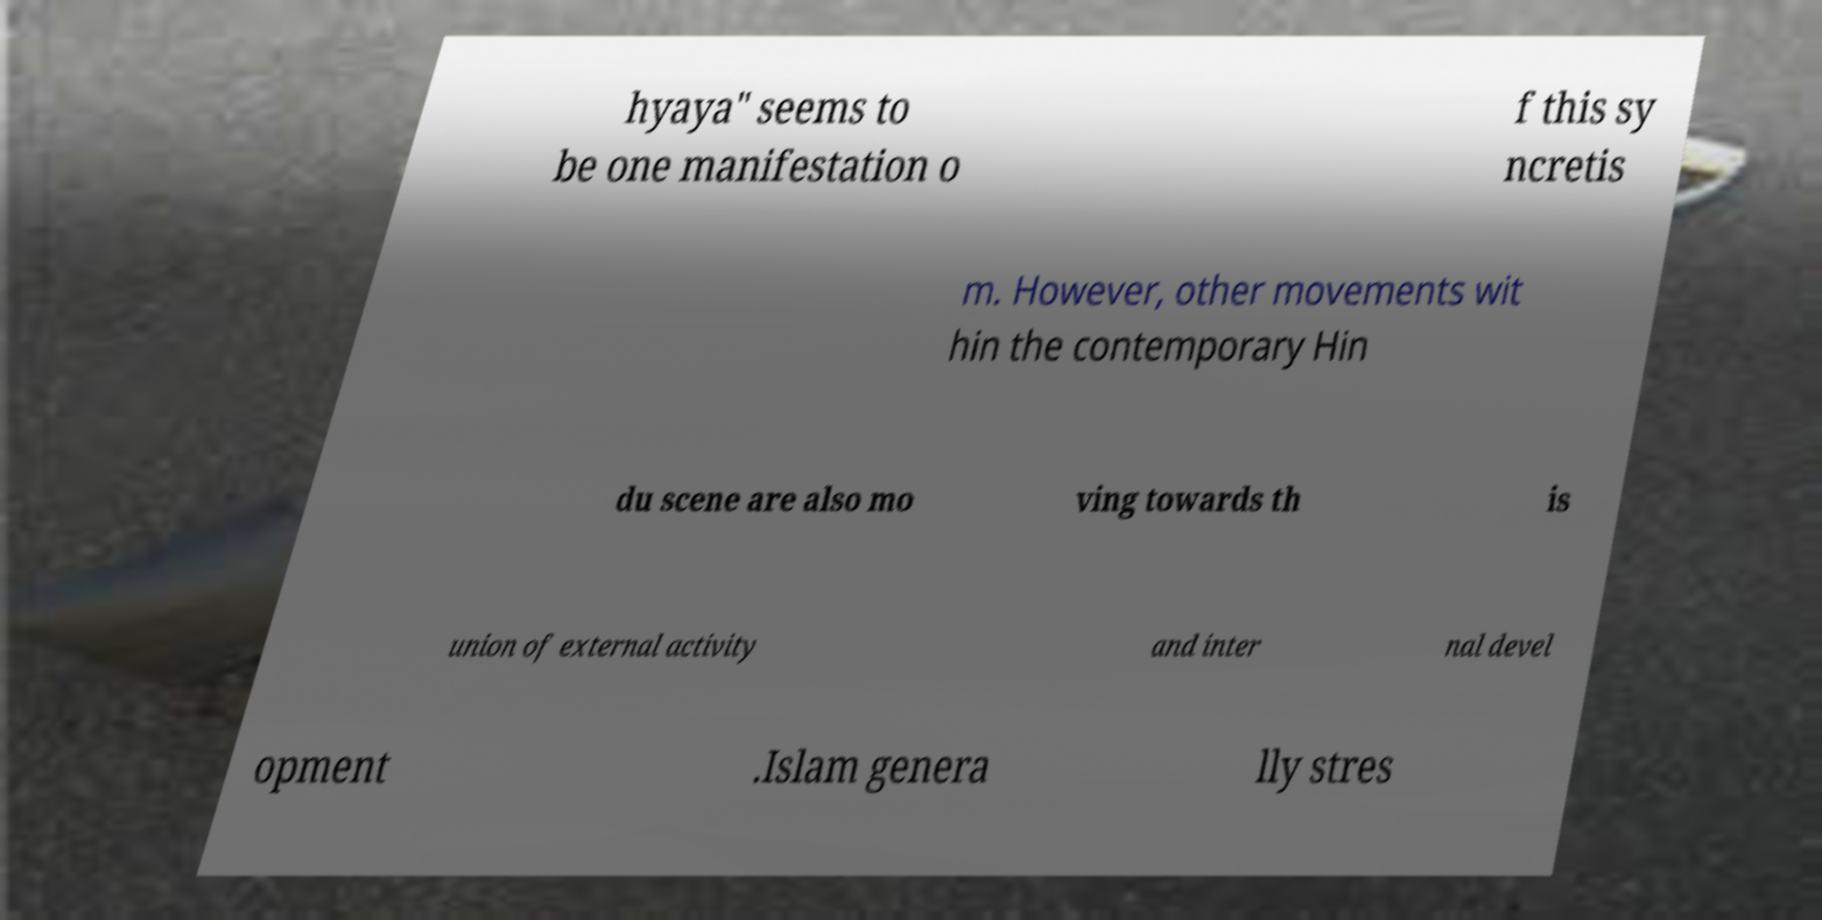Can you read and provide the text displayed in the image?This photo seems to have some interesting text. Can you extract and type it out for me? hyaya" seems to be one manifestation o f this sy ncretis m. However, other movements wit hin the contemporary Hin du scene are also mo ving towards th is union of external activity and inter nal devel opment .Islam genera lly stres 